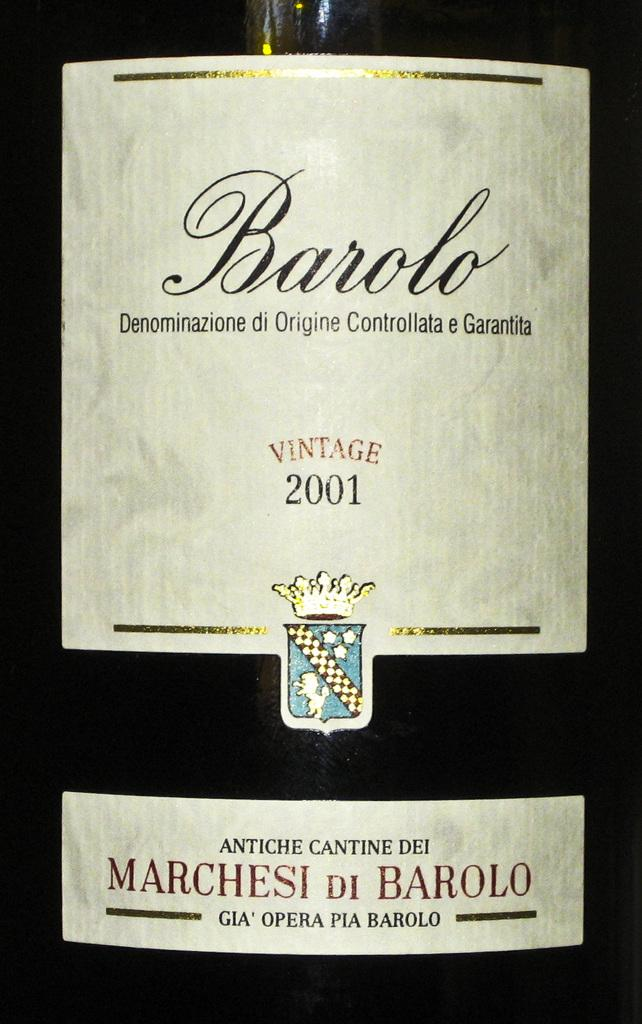Provide a one-sentence caption for the provided image. A wine label saying Barolo brand vintage wine from 2001 is shown. 